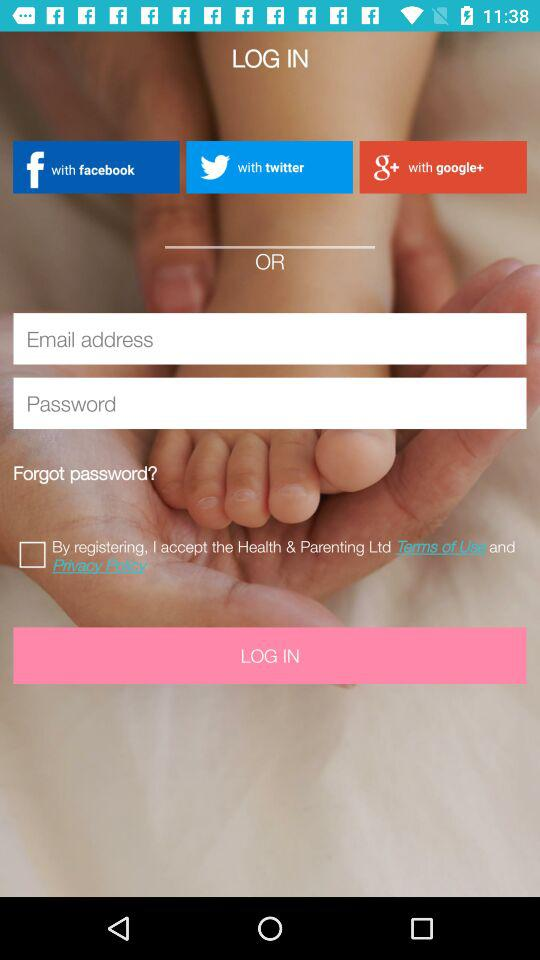How many characters are required to create a password?
When the provided information is insufficient, respond with <no answer>. <no answer> 